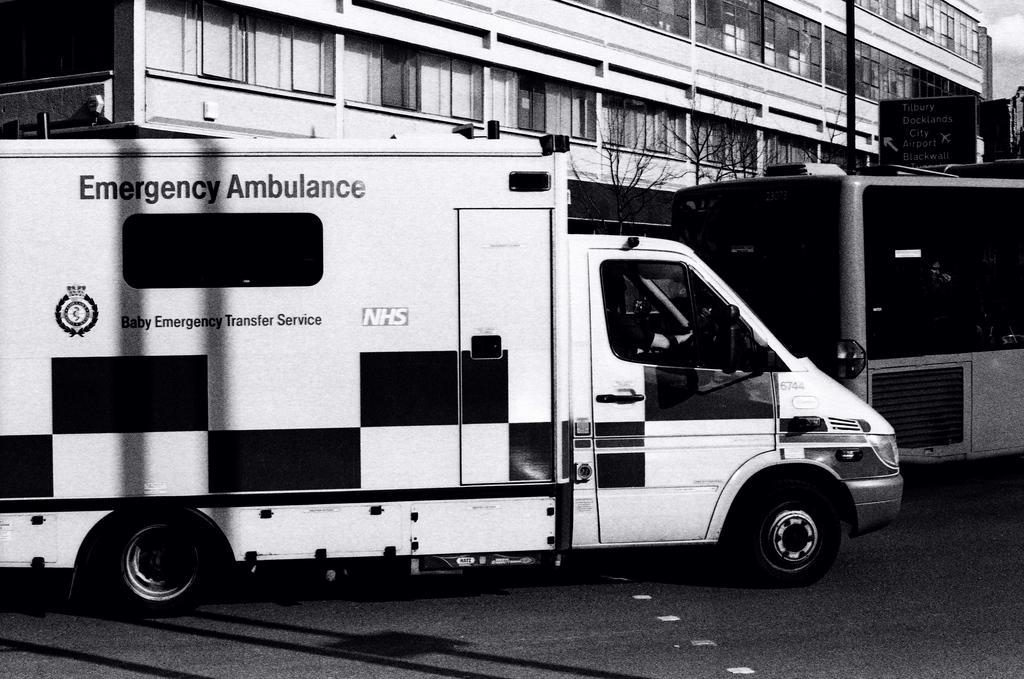Describe this image in one or two sentences. This is a black and white picture, there is an ambulance on the road and behind it there is a building with tree and bus in front of it. 